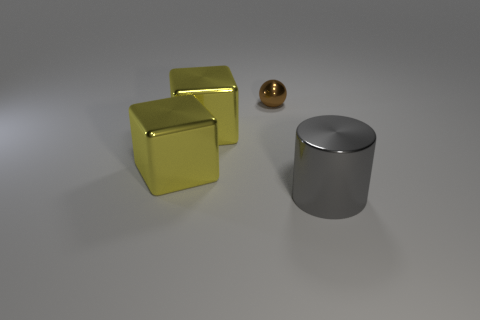Is there anything else that has the same size as the brown shiny thing?
Provide a short and direct response. No. How many objects are either cyan matte cubes or metal objects?
Your answer should be compact. 4. Does the sphere have the same size as the shiny thing on the right side of the ball?
Offer a terse response. No. The cylinder has what color?
Make the answer very short. Gray. Are there more big yellow cubes that are to the right of the gray thing than objects that are to the left of the small thing?
Your answer should be compact. No. Do the tiny brown metal thing and the shiny object right of the small brown metal object have the same shape?
Make the answer very short. No. Is the number of metallic cylinders that are right of the brown shiny object less than the number of small things that are in front of the large gray metallic cylinder?
Give a very brief answer. No. There is a brown object that is the same material as the gray thing; what shape is it?
Provide a short and direct response. Sphere. Is the number of gray shiny things greater than the number of purple things?
Keep it short and to the point. Yes. What number of other cylinders are the same size as the cylinder?
Your response must be concise. 0. 